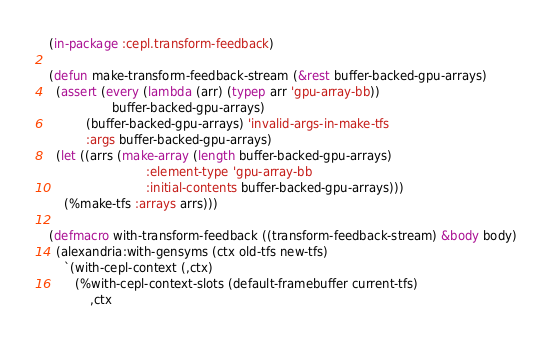<code> <loc_0><loc_0><loc_500><loc_500><_Lisp_>(in-package :cepl.transform-feedback)

(defun make-transform-feedback-stream (&rest buffer-backed-gpu-arrays)
  (assert (every (lambda (arr) (typep arr 'gpu-array-bb))
                 buffer-backed-gpu-arrays)
          (buffer-backed-gpu-arrays) 'invalid-args-in-make-tfs
          :args buffer-backed-gpu-arrays)
  (let ((arrs (make-array (length buffer-backed-gpu-arrays)
                          :element-type 'gpu-array-bb
                          :initial-contents buffer-backed-gpu-arrays)))
    (%make-tfs :arrays arrs)))

(defmacro with-transform-feedback ((transform-feedback-stream) &body body)
  (alexandria:with-gensyms (ctx old-tfs new-tfs)
    `(with-cepl-context (,ctx)
       (%with-cepl-context-slots (default-framebuffer current-tfs)
           ,ctx</code> 